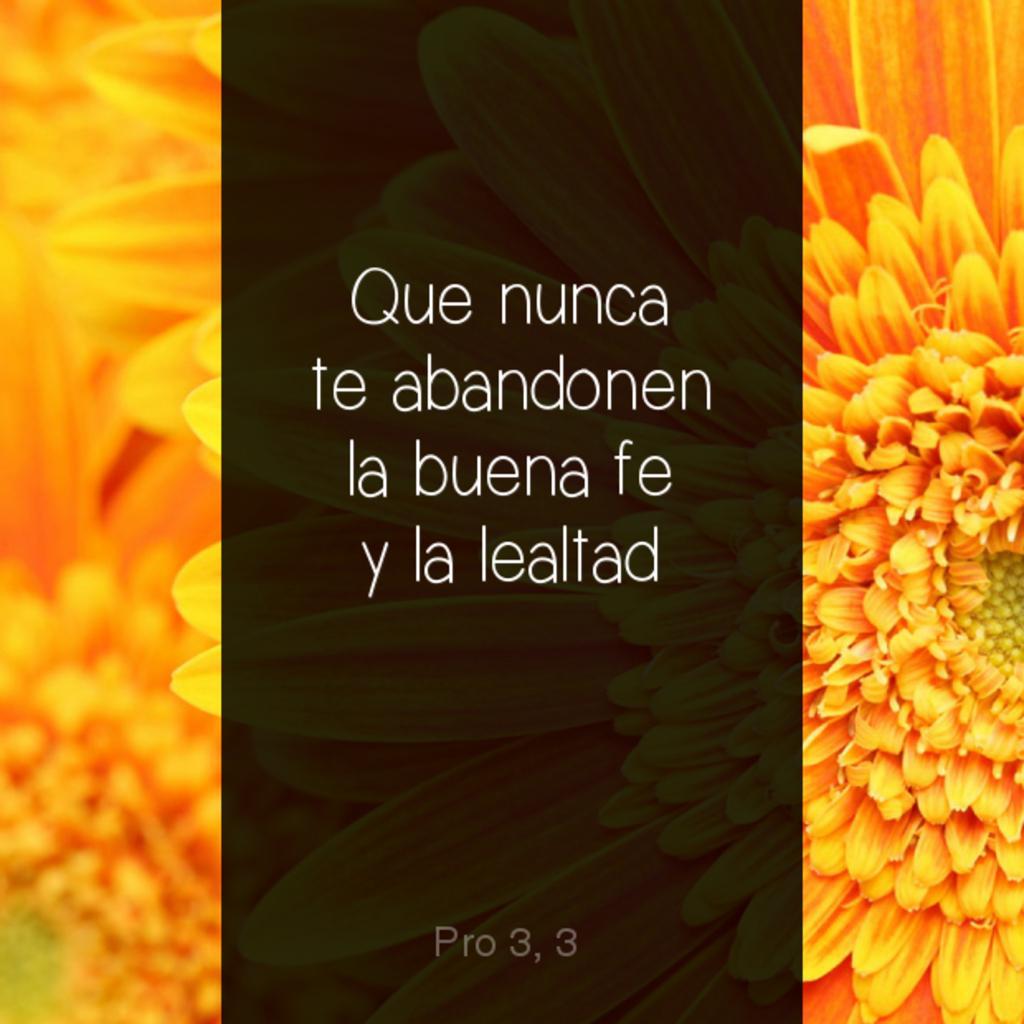Please provide a concise description of this image. In this picture I can see a poster with some text in the middle and at the bottom of the picture and I can see couple of flowers on the left and right side of the picture. 